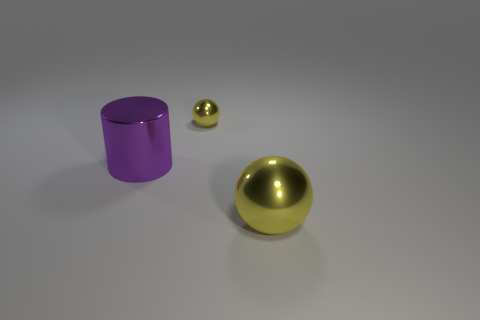Add 3 large purple metal objects. How many objects exist? 6 Subtract all spheres. How many objects are left? 1 Add 1 metal balls. How many metal balls are left? 3 Add 2 tiny objects. How many tiny objects exist? 3 Subtract 0 brown cubes. How many objects are left? 3 Subtract all large red metal cubes. Subtract all metallic spheres. How many objects are left? 1 